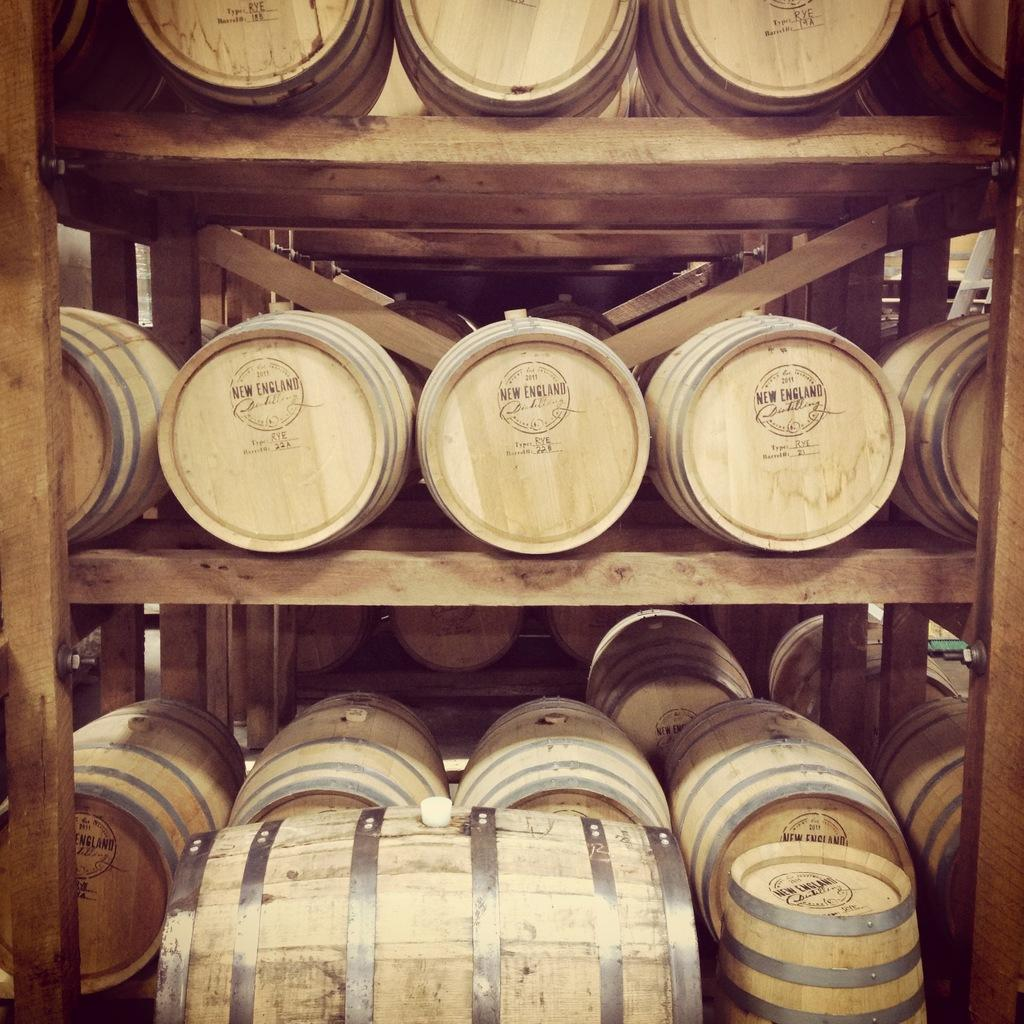What objects are present in the image? There are barrels in the image. How are the barrels arranged or stored? The barrels are kept in wooden racks. What is the price of the disgusting box in the image? There is no box or any indication of disgust in the image; it only features barrels stored in wooden racks. 